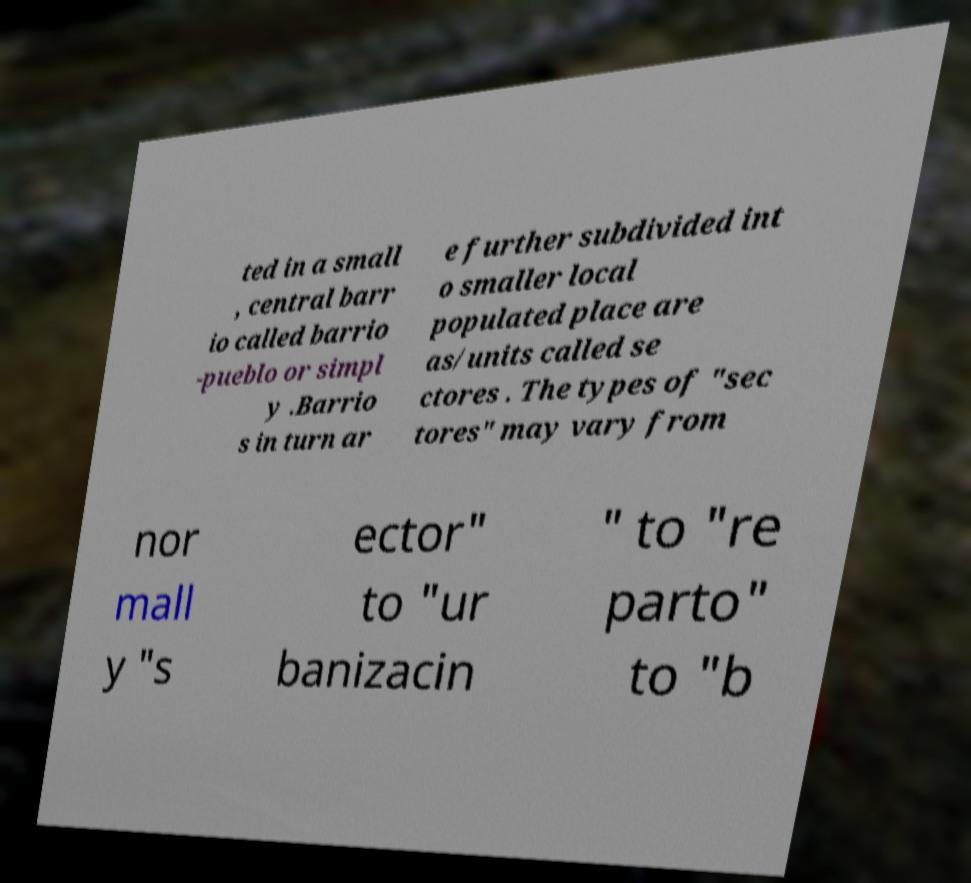Please identify and transcribe the text found in this image. ted in a small , central barr io called barrio -pueblo or simpl y .Barrio s in turn ar e further subdivided int o smaller local populated place are as/units called se ctores . The types of "sec tores" may vary from nor mall y "s ector" to "ur banizacin " to "re parto" to "b 